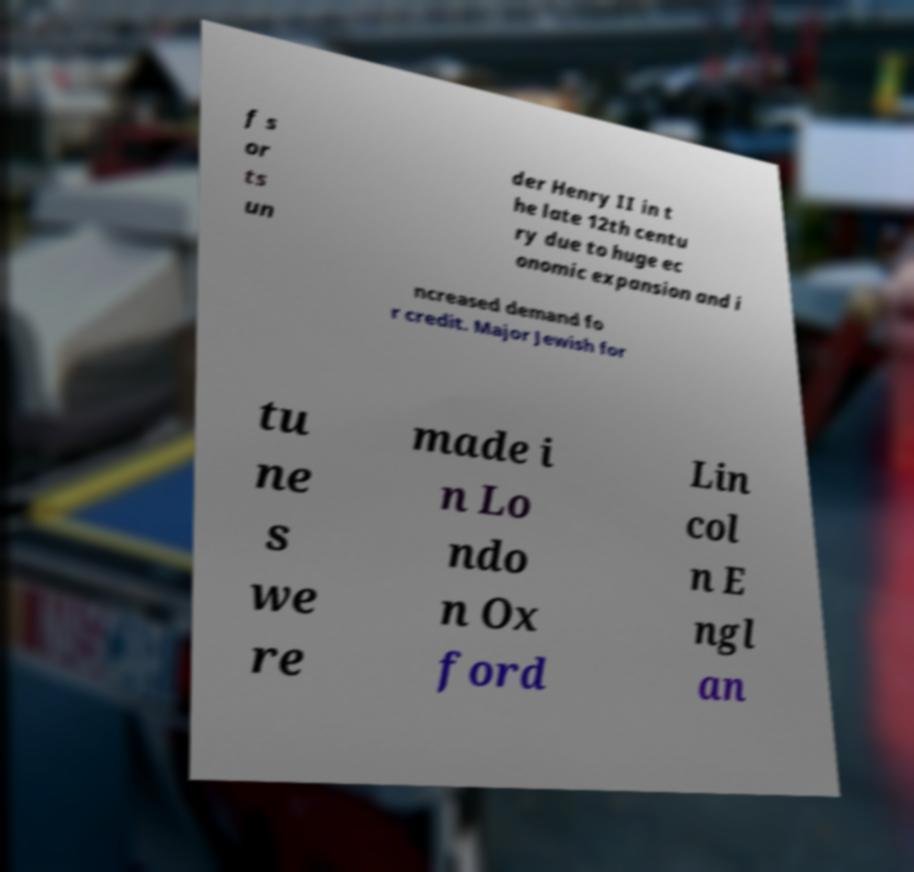Could you extract and type out the text from this image? f s or ts un der Henry II in t he late 12th centu ry due to huge ec onomic expansion and i ncreased demand fo r credit. Major Jewish for tu ne s we re made i n Lo ndo n Ox ford Lin col n E ngl an 